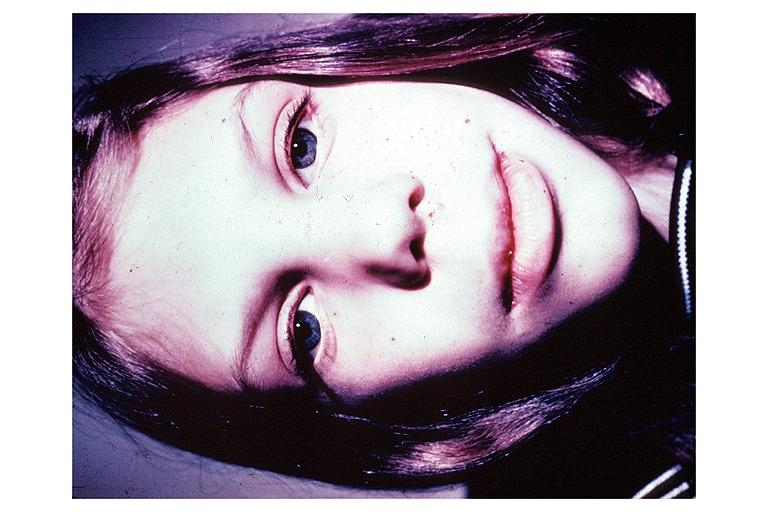where is this?
Answer the question using a single word or phrase. Oral 